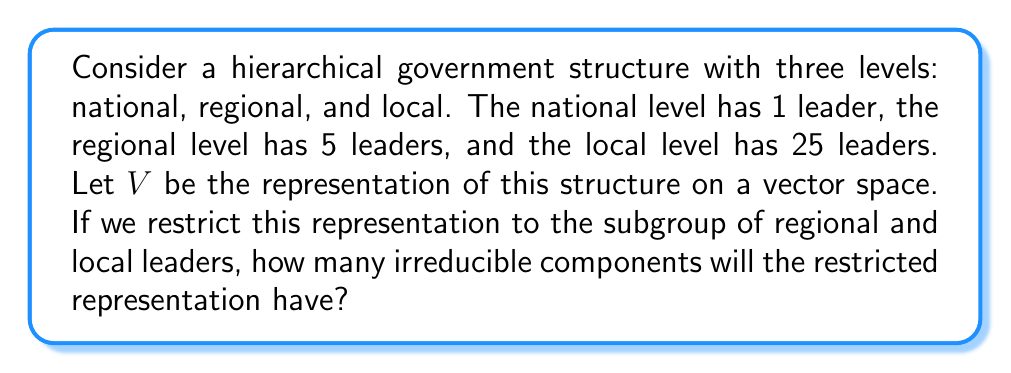Help me with this question. To solve this problem, we need to apply the concept of branching rules in representation theory:

1) First, let's identify the groups involved:
   - $G$: The full group (all levels)
   - $H$: The subgroup (regional and local levels)

2) The representation $V$ of $G$ can be thought of as a 31-dimensional vector space (1 + 5 + 25 = 31 leaders total).

3) When we restrict this representation to $H$, we're essentially looking at how $V$ decomposes as an $H$-representation.

4) In this case, the restriction will separate the national leader from the rest:

   $$V|_H = V_1 \oplus V_2$$

   Where $V_1$ is the 1-dimensional subspace corresponding to the national leader, and $V_2$ is the 30-dimensional subspace corresponding to regional and local leaders.

5) $V_1$ is already irreducible as a 1-dimensional representation.

6) $V_2$ will further decompose into two irreducible components:
   
   $$V_2 = W_1 \oplus W_2$$

   Where $W_1$ is a 5-dimensional subspace for regional leaders, and $W_2$ is a 25-dimensional subspace for local leaders.

7) Therefore, the total number of irreducible components in the restricted representation is 3:
   - $V_1$: 1-dimensional (national leader)
   - $W_1$: 5-dimensional (regional leaders)
   - $W_2$: 25-dimensional (local leaders)
Answer: 3 